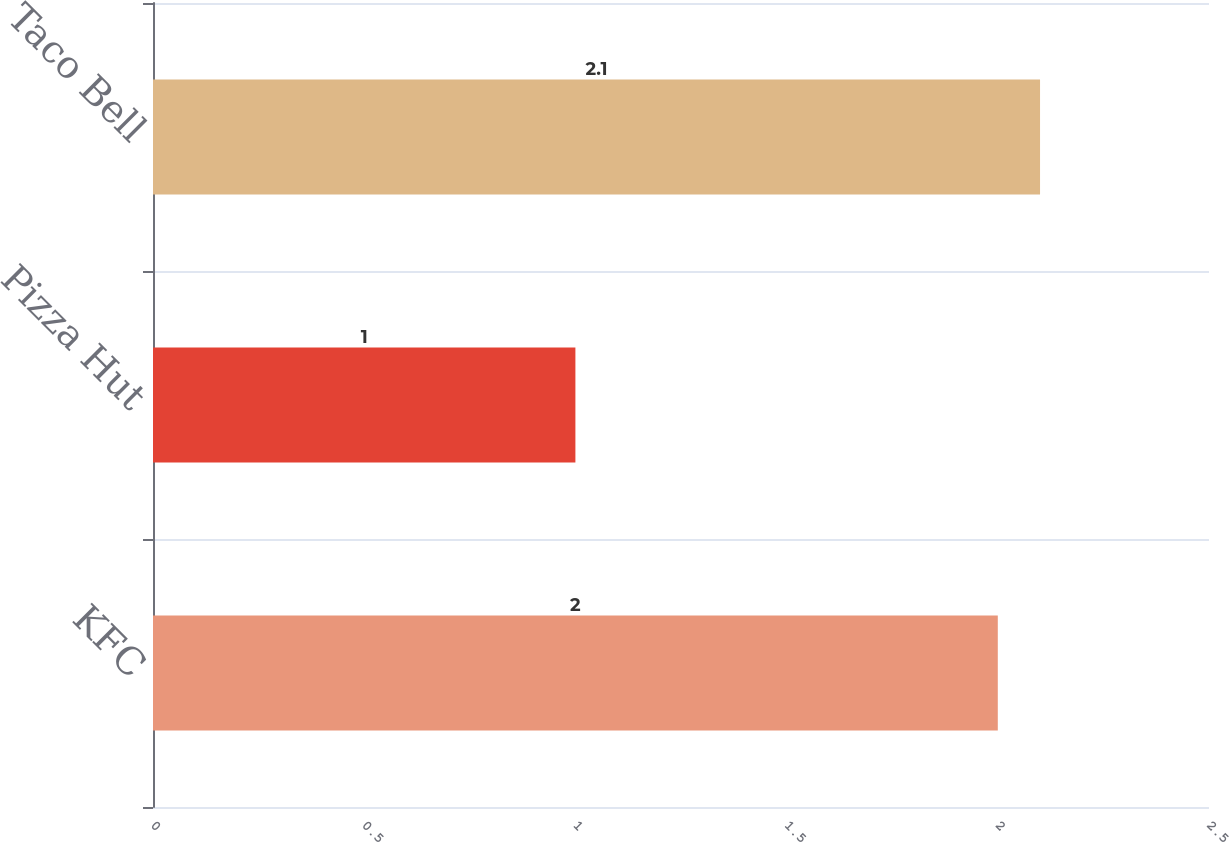<chart> <loc_0><loc_0><loc_500><loc_500><bar_chart><fcel>KFC<fcel>Pizza Hut<fcel>Taco Bell<nl><fcel>2<fcel>1<fcel>2.1<nl></chart> 